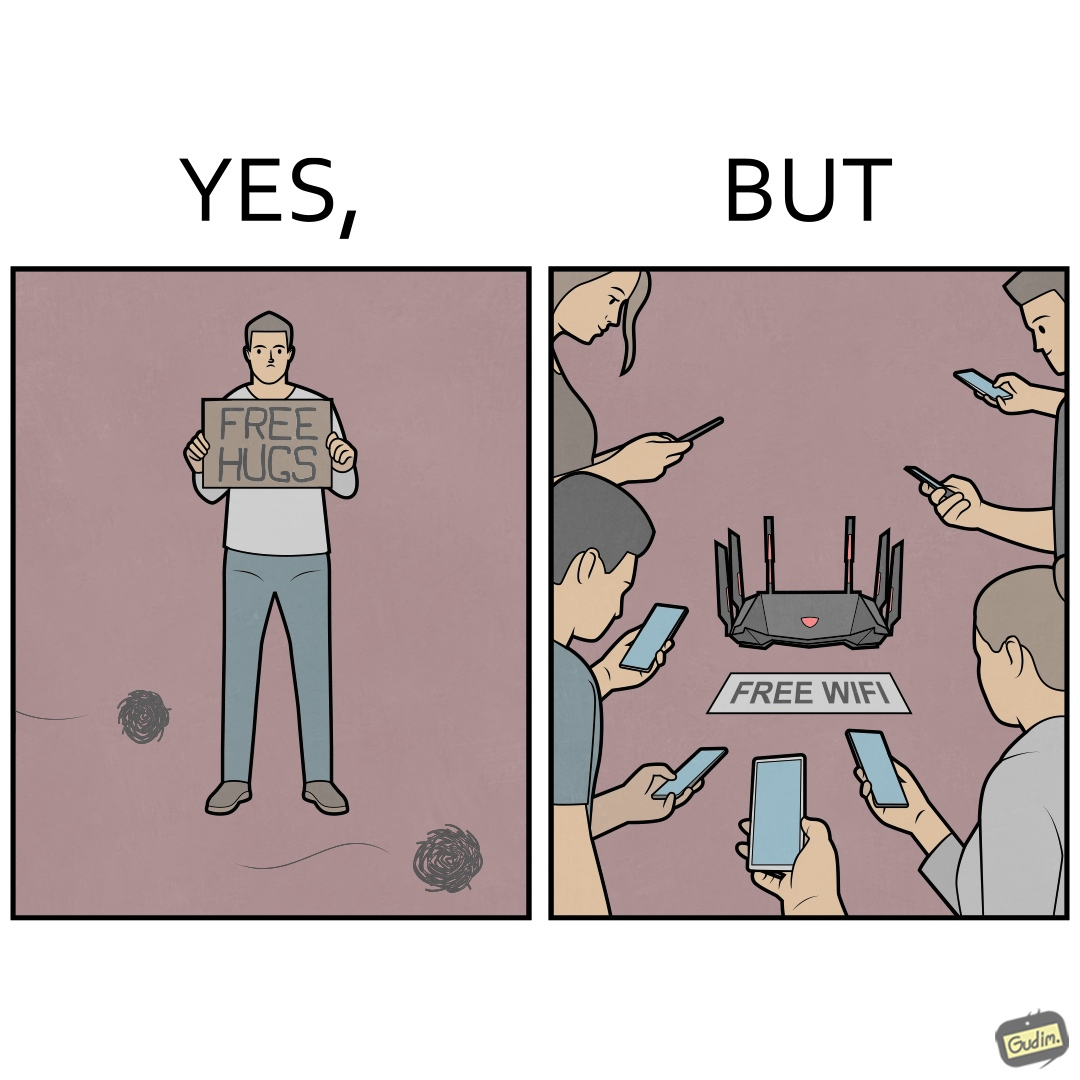Would you classify this image as satirical? Yes, this image is satirical. 